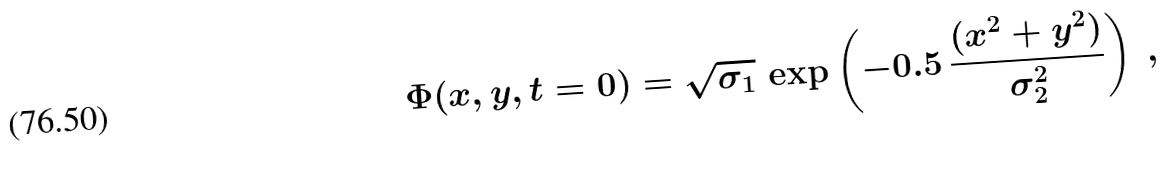<formula> <loc_0><loc_0><loc_500><loc_500>\Phi ( x , y , t = 0 ) = \sqrt { \sigma _ { 1 } } \, \exp \left ( - 0 . 5 \, \frac { ( x ^ { 2 } + y ^ { 2 } ) } { \sigma _ { 2 } ^ { 2 } } \right ) \ ,</formula> 